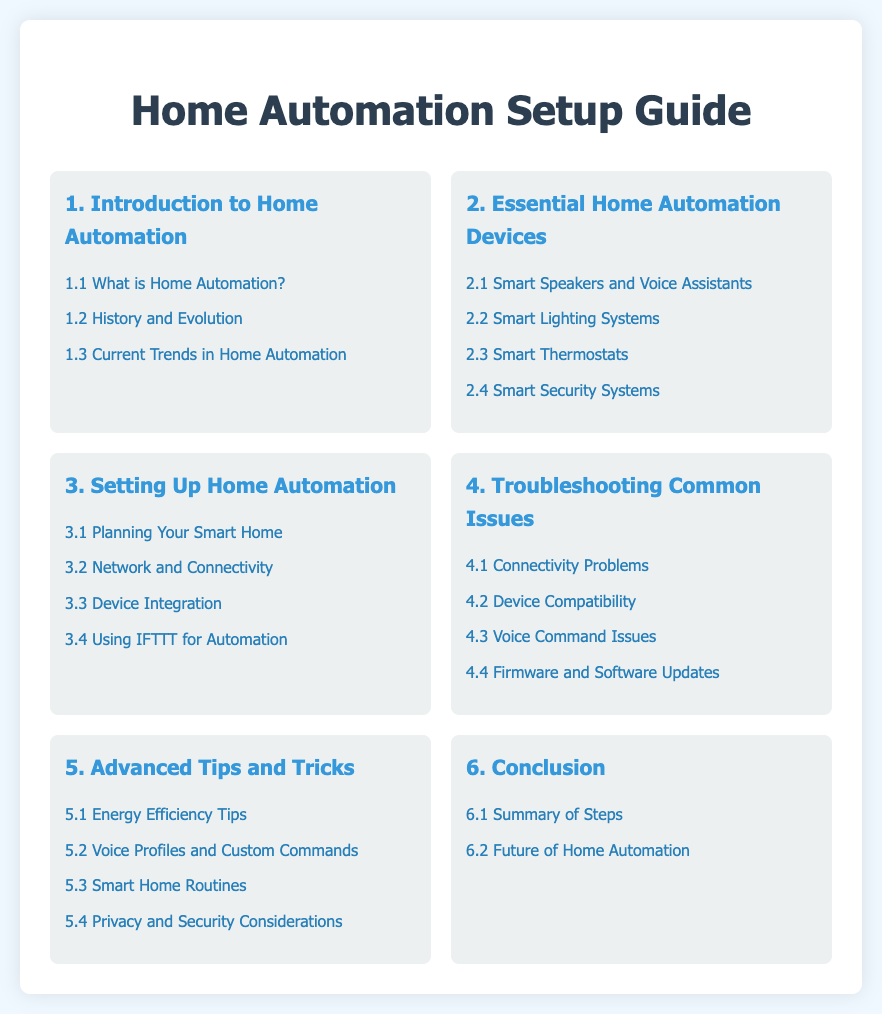What is the title of the document? The title of the document is displayed prominently at the top of the page.
Answer: Home Automation Setup Guide How many sections are in the Table of Contents? The sections are counted in the Table of Contents displayed in the document.
Answer: 6 What does section 3 discuss? Section 3 includes various topics related to setting up home automation systems.
Answer: Setting Up Home Automation Which device is mentioned under essential home automation devices? The essential devices listed in this section can be found under the second section of the document.
Answer: Smart Speakers and Voice Assistants What is one troubleshooting topic covered in the document? The troubleshooting topics are listed in section 4 of the document.
Answer: Connectivity Problems How many subsections are under the 'Advanced Tips and Tricks' section? The number of subsections can be identified by counting the list items in section 5.
Answer: 4 Which subsection focuses on voice command issues? This specific topic is addressed in one of the subsections in the troubleshooting section.
Answer: 4.3 Voice Command Issues What is the focus of section 1? The first section discusses the general concept of home automation.
Answer: Introduction to Home Automation 